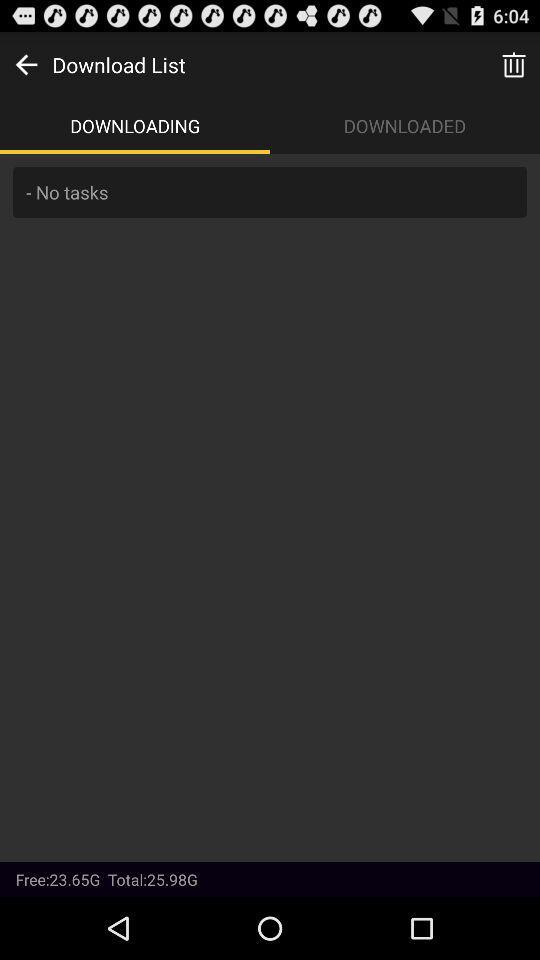What amount of storage is free? The available storage is 23.65 G. 